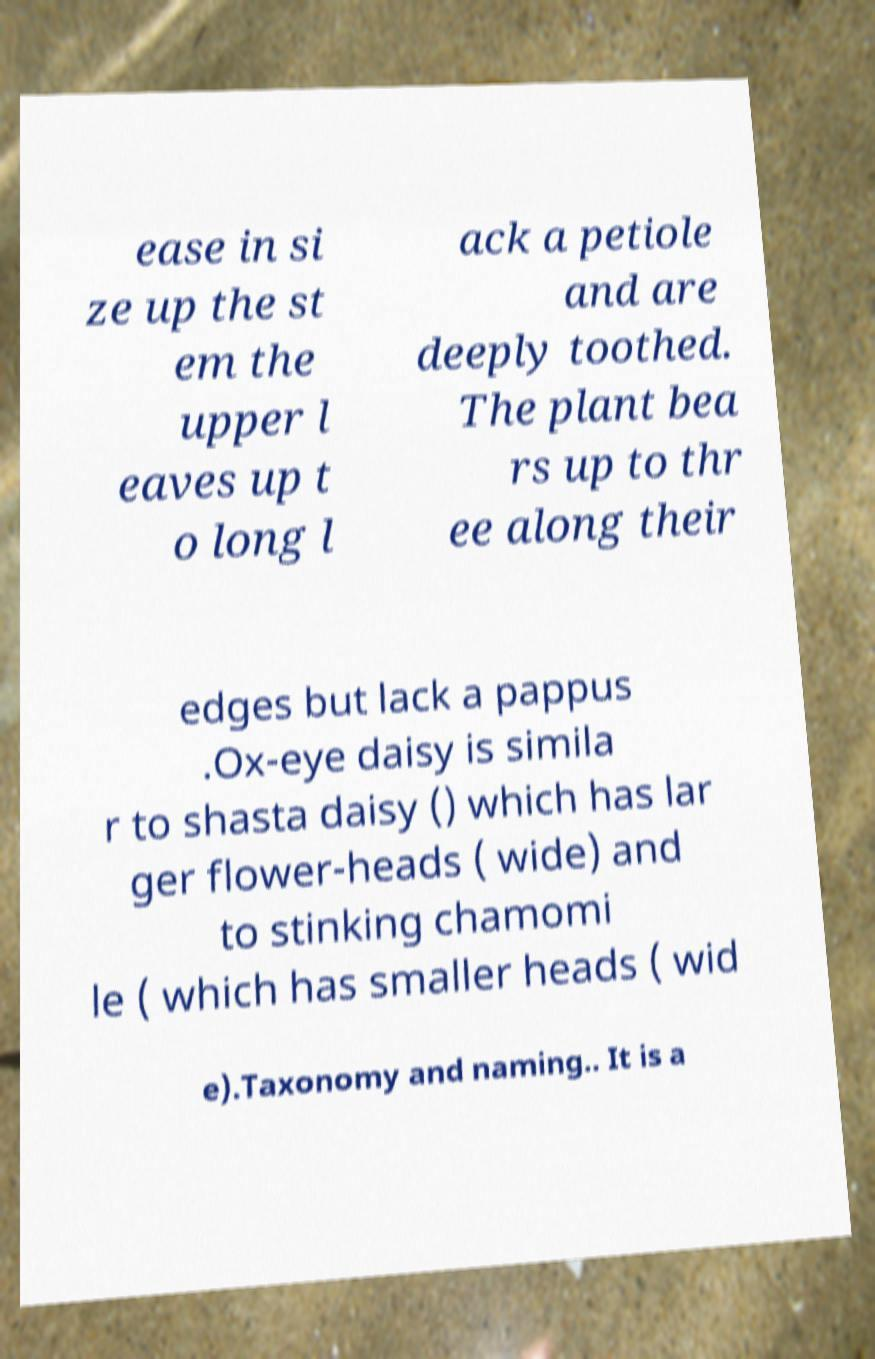I need the written content from this picture converted into text. Can you do that? ease in si ze up the st em the upper l eaves up t o long l ack a petiole and are deeply toothed. The plant bea rs up to thr ee along their edges but lack a pappus .Ox-eye daisy is simila r to shasta daisy () which has lar ger flower-heads ( wide) and to stinking chamomi le ( which has smaller heads ( wid e).Taxonomy and naming.. It is a 